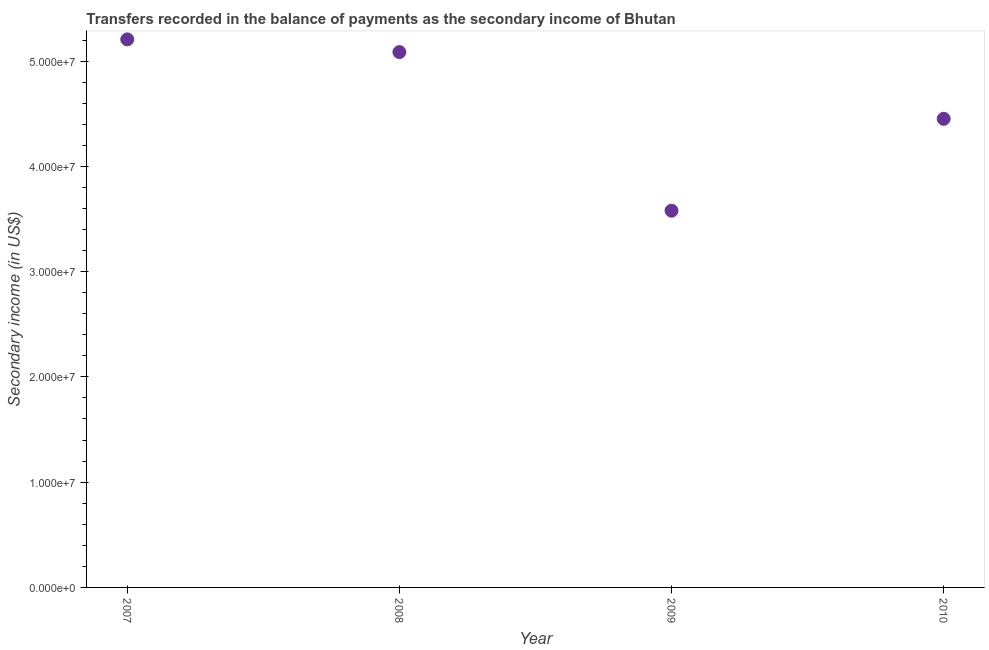What is the amount of secondary income in 2010?
Offer a very short reply. 4.45e+07. Across all years, what is the maximum amount of secondary income?
Offer a very short reply. 5.21e+07. Across all years, what is the minimum amount of secondary income?
Your response must be concise. 3.58e+07. What is the sum of the amount of secondary income?
Provide a succinct answer. 1.83e+08. What is the difference between the amount of secondary income in 2009 and 2010?
Offer a terse response. -8.73e+06. What is the average amount of secondary income per year?
Give a very brief answer. 4.58e+07. What is the median amount of secondary income?
Offer a terse response. 4.77e+07. In how many years, is the amount of secondary income greater than 24000000 US$?
Give a very brief answer. 4. Do a majority of the years between 2007 and 2008 (inclusive) have amount of secondary income greater than 12000000 US$?
Your answer should be very brief. Yes. What is the ratio of the amount of secondary income in 2009 to that in 2010?
Your answer should be compact. 0.8. Is the amount of secondary income in 2008 less than that in 2010?
Your answer should be compact. No. What is the difference between the highest and the second highest amount of secondary income?
Your answer should be very brief. 1.21e+06. What is the difference between the highest and the lowest amount of secondary income?
Offer a terse response. 1.63e+07. In how many years, is the amount of secondary income greater than the average amount of secondary income taken over all years?
Ensure brevity in your answer.  2. How many years are there in the graph?
Offer a very short reply. 4. Are the values on the major ticks of Y-axis written in scientific E-notation?
Your answer should be compact. Yes. Does the graph contain grids?
Your response must be concise. No. What is the title of the graph?
Keep it short and to the point. Transfers recorded in the balance of payments as the secondary income of Bhutan. What is the label or title of the Y-axis?
Provide a short and direct response. Secondary income (in US$). What is the Secondary income (in US$) in 2007?
Keep it short and to the point. 5.21e+07. What is the Secondary income (in US$) in 2008?
Keep it short and to the point. 5.09e+07. What is the Secondary income (in US$) in 2009?
Your answer should be very brief. 3.58e+07. What is the Secondary income (in US$) in 2010?
Offer a very short reply. 4.45e+07. What is the difference between the Secondary income (in US$) in 2007 and 2008?
Offer a terse response. 1.21e+06. What is the difference between the Secondary income (in US$) in 2007 and 2009?
Offer a terse response. 1.63e+07. What is the difference between the Secondary income (in US$) in 2007 and 2010?
Ensure brevity in your answer.  7.54e+06. What is the difference between the Secondary income (in US$) in 2008 and 2009?
Make the answer very short. 1.51e+07. What is the difference between the Secondary income (in US$) in 2008 and 2010?
Provide a short and direct response. 6.34e+06. What is the difference between the Secondary income (in US$) in 2009 and 2010?
Your answer should be very brief. -8.73e+06. What is the ratio of the Secondary income (in US$) in 2007 to that in 2009?
Keep it short and to the point. 1.46. What is the ratio of the Secondary income (in US$) in 2007 to that in 2010?
Provide a succinct answer. 1.17. What is the ratio of the Secondary income (in US$) in 2008 to that in 2009?
Your response must be concise. 1.42. What is the ratio of the Secondary income (in US$) in 2008 to that in 2010?
Ensure brevity in your answer.  1.14. What is the ratio of the Secondary income (in US$) in 2009 to that in 2010?
Your answer should be compact. 0.8. 